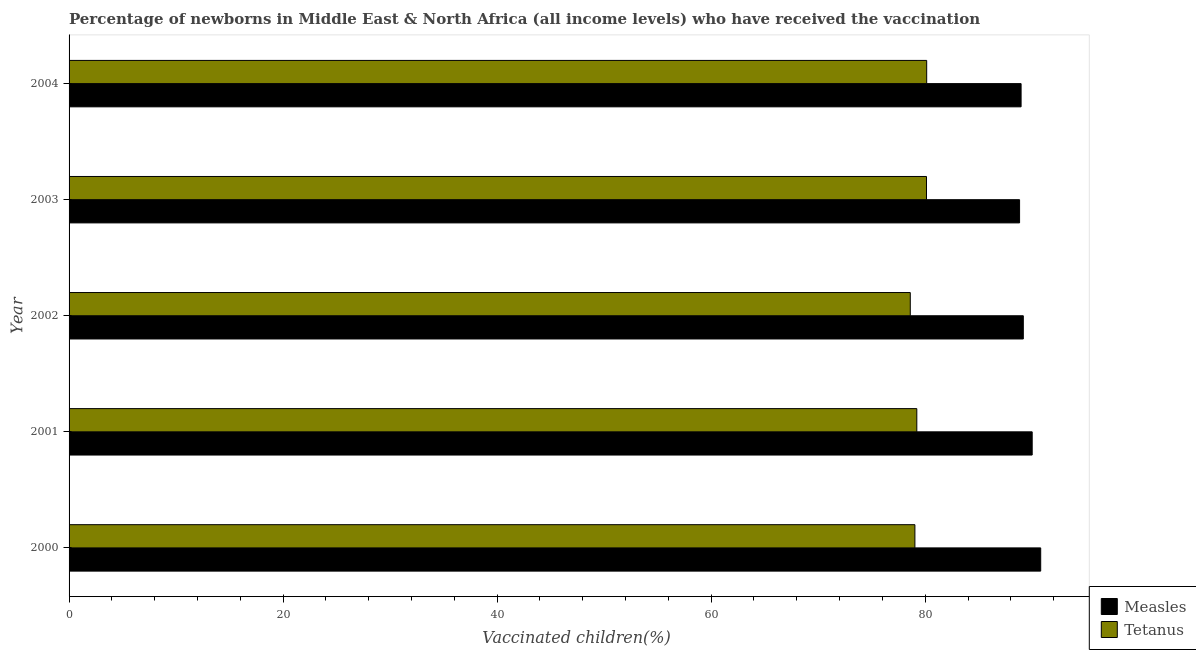How many different coloured bars are there?
Provide a succinct answer. 2. How many groups of bars are there?
Give a very brief answer. 5. Are the number of bars on each tick of the Y-axis equal?
Provide a short and direct response. Yes. How many bars are there on the 5th tick from the bottom?
Offer a terse response. 2. What is the percentage of newborns who received vaccination for measles in 2000?
Provide a succinct answer. 90.79. Across all years, what is the maximum percentage of newborns who received vaccination for tetanus?
Your response must be concise. 80.14. Across all years, what is the minimum percentage of newborns who received vaccination for tetanus?
Your response must be concise. 78.6. What is the total percentage of newborns who received vaccination for tetanus in the graph?
Make the answer very short. 397.11. What is the difference between the percentage of newborns who received vaccination for tetanus in 2000 and that in 2001?
Give a very brief answer. -0.18. What is the difference between the percentage of newborns who received vaccination for tetanus in 2000 and the percentage of newborns who received vaccination for measles in 2004?
Ensure brevity in your answer.  -9.92. What is the average percentage of newborns who received vaccination for tetanus per year?
Keep it short and to the point. 79.42. In the year 2003, what is the difference between the percentage of newborns who received vaccination for measles and percentage of newborns who received vaccination for tetanus?
Give a very brief answer. 8.7. In how many years, is the percentage of newborns who received vaccination for tetanus greater than 8 %?
Offer a terse response. 5. Is the percentage of newborns who received vaccination for tetanus in 2003 less than that in 2004?
Offer a terse response. Yes. What is the difference between the highest and the second highest percentage of newborns who received vaccination for tetanus?
Make the answer very short. 0.02. What is the difference between the highest and the lowest percentage of newborns who received vaccination for tetanus?
Your answer should be compact. 1.53. What does the 1st bar from the top in 2000 represents?
Ensure brevity in your answer.  Tetanus. What does the 1st bar from the bottom in 2001 represents?
Offer a terse response. Measles. How many bars are there?
Ensure brevity in your answer.  10. How many years are there in the graph?
Offer a terse response. 5. What is the difference between two consecutive major ticks on the X-axis?
Make the answer very short. 20. Are the values on the major ticks of X-axis written in scientific E-notation?
Your response must be concise. No. Does the graph contain any zero values?
Give a very brief answer. No. Does the graph contain grids?
Provide a succinct answer. No. Where does the legend appear in the graph?
Provide a short and direct response. Bottom right. How are the legend labels stacked?
Offer a terse response. Vertical. What is the title of the graph?
Make the answer very short. Percentage of newborns in Middle East & North Africa (all income levels) who have received the vaccination. What is the label or title of the X-axis?
Keep it short and to the point. Vaccinated children(%)
. What is the Vaccinated children(%)
 of Measles in 2000?
Provide a short and direct response. 90.79. What is the Vaccinated children(%)
 of Tetanus in 2000?
Offer a very short reply. 79.04. What is the Vaccinated children(%)
 of Measles in 2001?
Your answer should be compact. 90. What is the Vaccinated children(%)
 in Tetanus in 2001?
Give a very brief answer. 79.22. What is the Vaccinated children(%)
 in Measles in 2002?
Your response must be concise. 89.17. What is the Vaccinated children(%)
 in Tetanus in 2002?
Ensure brevity in your answer.  78.6. What is the Vaccinated children(%)
 of Measles in 2003?
Keep it short and to the point. 88.82. What is the Vaccinated children(%)
 in Tetanus in 2003?
Ensure brevity in your answer.  80.12. What is the Vaccinated children(%)
 of Measles in 2004?
Offer a terse response. 88.96. What is the Vaccinated children(%)
 of Tetanus in 2004?
Make the answer very short. 80.14. Across all years, what is the maximum Vaccinated children(%)
 in Measles?
Your answer should be very brief. 90.79. Across all years, what is the maximum Vaccinated children(%)
 in Tetanus?
Give a very brief answer. 80.14. Across all years, what is the minimum Vaccinated children(%)
 in Measles?
Your response must be concise. 88.82. Across all years, what is the minimum Vaccinated children(%)
 in Tetanus?
Offer a terse response. 78.6. What is the total Vaccinated children(%)
 in Measles in the graph?
Your answer should be compact. 447.73. What is the total Vaccinated children(%)
 in Tetanus in the graph?
Offer a very short reply. 397.11. What is the difference between the Vaccinated children(%)
 of Measles in 2000 and that in 2001?
Ensure brevity in your answer.  0.8. What is the difference between the Vaccinated children(%)
 of Tetanus in 2000 and that in 2001?
Keep it short and to the point. -0.18. What is the difference between the Vaccinated children(%)
 of Measles in 2000 and that in 2002?
Offer a terse response. 1.63. What is the difference between the Vaccinated children(%)
 of Tetanus in 2000 and that in 2002?
Your answer should be compact. 0.43. What is the difference between the Vaccinated children(%)
 of Measles in 2000 and that in 2003?
Your answer should be compact. 1.97. What is the difference between the Vaccinated children(%)
 in Tetanus in 2000 and that in 2003?
Provide a short and direct response. -1.08. What is the difference between the Vaccinated children(%)
 in Measles in 2000 and that in 2004?
Offer a very short reply. 1.83. What is the difference between the Vaccinated children(%)
 of Tetanus in 2000 and that in 2004?
Provide a succinct answer. -1.1. What is the difference between the Vaccinated children(%)
 of Measles in 2001 and that in 2002?
Offer a terse response. 0.83. What is the difference between the Vaccinated children(%)
 in Tetanus in 2001 and that in 2002?
Your answer should be compact. 0.61. What is the difference between the Vaccinated children(%)
 in Measles in 2001 and that in 2003?
Offer a very short reply. 1.18. What is the difference between the Vaccinated children(%)
 in Tetanus in 2001 and that in 2003?
Offer a very short reply. -0.91. What is the difference between the Vaccinated children(%)
 in Measles in 2001 and that in 2004?
Ensure brevity in your answer.  1.04. What is the difference between the Vaccinated children(%)
 in Tetanus in 2001 and that in 2004?
Provide a succinct answer. -0.92. What is the difference between the Vaccinated children(%)
 of Measles in 2002 and that in 2003?
Your answer should be compact. 0.35. What is the difference between the Vaccinated children(%)
 of Tetanus in 2002 and that in 2003?
Offer a terse response. -1.52. What is the difference between the Vaccinated children(%)
 of Measles in 2002 and that in 2004?
Provide a short and direct response. 0.21. What is the difference between the Vaccinated children(%)
 of Tetanus in 2002 and that in 2004?
Ensure brevity in your answer.  -1.53. What is the difference between the Vaccinated children(%)
 in Measles in 2003 and that in 2004?
Keep it short and to the point. -0.14. What is the difference between the Vaccinated children(%)
 in Tetanus in 2003 and that in 2004?
Your answer should be compact. -0.02. What is the difference between the Vaccinated children(%)
 in Measles in 2000 and the Vaccinated children(%)
 in Tetanus in 2001?
Your answer should be compact. 11.58. What is the difference between the Vaccinated children(%)
 in Measles in 2000 and the Vaccinated children(%)
 in Tetanus in 2002?
Give a very brief answer. 12.19. What is the difference between the Vaccinated children(%)
 in Measles in 2000 and the Vaccinated children(%)
 in Tetanus in 2003?
Your response must be concise. 10.67. What is the difference between the Vaccinated children(%)
 in Measles in 2000 and the Vaccinated children(%)
 in Tetanus in 2004?
Make the answer very short. 10.65. What is the difference between the Vaccinated children(%)
 of Measles in 2001 and the Vaccinated children(%)
 of Tetanus in 2002?
Offer a very short reply. 11.39. What is the difference between the Vaccinated children(%)
 in Measles in 2001 and the Vaccinated children(%)
 in Tetanus in 2003?
Give a very brief answer. 9.87. What is the difference between the Vaccinated children(%)
 in Measles in 2001 and the Vaccinated children(%)
 in Tetanus in 2004?
Make the answer very short. 9.86. What is the difference between the Vaccinated children(%)
 in Measles in 2002 and the Vaccinated children(%)
 in Tetanus in 2003?
Your answer should be compact. 9.05. What is the difference between the Vaccinated children(%)
 in Measles in 2002 and the Vaccinated children(%)
 in Tetanus in 2004?
Give a very brief answer. 9.03. What is the difference between the Vaccinated children(%)
 of Measles in 2003 and the Vaccinated children(%)
 of Tetanus in 2004?
Provide a succinct answer. 8.68. What is the average Vaccinated children(%)
 of Measles per year?
Offer a terse response. 89.55. What is the average Vaccinated children(%)
 in Tetanus per year?
Offer a terse response. 79.42. In the year 2000, what is the difference between the Vaccinated children(%)
 in Measles and Vaccinated children(%)
 in Tetanus?
Ensure brevity in your answer.  11.76. In the year 2001, what is the difference between the Vaccinated children(%)
 in Measles and Vaccinated children(%)
 in Tetanus?
Your answer should be compact. 10.78. In the year 2002, what is the difference between the Vaccinated children(%)
 in Measles and Vaccinated children(%)
 in Tetanus?
Your answer should be compact. 10.56. In the year 2003, what is the difference between the Vaccinated children(%)
 of Measles and Vaccinated children(%)
 of Tetanus?
Your response must be concise. 8.7. In the year 2004, what is the difference between the Vaccinated children(%)
 of Measles and Vaccinated children(%)
 of Tetanus?
Keep it short and to the point. 8.82. What is the ratio of the Vaccinated children(%)
 in Measles in 2000 to that in 2001?
Ensure brevity in your answer.  1.01. What is the ratio of the Vaccinated children(%)
 of Measles in 2000 to that in 2002?
Your answer should be compact. 1.02. What is the ratio of the Vaccinated children(%)
 in Tetanus in 2000 to that in 2002?
Give a very brief answer. 1.01. What is the ratio of the Vaccinated children(%)
 of Measles in 2000 to that in 2003?
Your answer should be compact. 1.02. What is the ratio of the Vaccinated children(%)
 in Tetanus in 2000 to that in 2003?
Make the answer very short. 0.99. What is the ratio of the Vaccinated children(%)
 in Measles in 2000 to that in 2004?
Give a very brief answer. 1.02. What is the ratio of the Vaccinated children(%)
 in Tetanus in 2000 to that in 2004?
Your answer should be compact. 0.99. What is the ratio of the Vaccinated children(%)
 of Measles in 2001 to that in 2002?
Provide a short and direct response. 1.01. What is the ratio of the Vaccinated children(%)
 of Measles in 2001 to that in 2003?
Your response must be concise. 1.01. What is the ratio of the Vaccinated children(%)
 in Tetanus in 2001 to that in 2003?
Provide a short and direct response. 0.99. What is the ratio of the Vaccinated children(%)
 of Measles in 2001 to that in 2004?
Your answer should be very brief. 1.01. What is the ratio of the Vaccinated children(%)
 of Tetanus in 2002 to that in 2003?
Provide a short and direct response. 0.98. What is the ratio of the Vaccinated children(%)
 of Tetanus in 2002 to that in 2004?
Give a very brief answer. 0.98. What is the ratio of the Vaccinated children(%)
 in Measles in 2003 to that in 2004?
Make the answer very short. 1. What is the ratio of the Vaccinated children(%)
 of Tetanus in 2003 to that in 2004?
Offer a terse response. 1. What is the difference between the highest and the second highest Vaccinated children(%)
 of Measles?
Keep it short and to the point. 0.8. What is the difference between the highest and the second highest Vaccinated children(%)
 in Tetanus?
Your answer should be compact. 0.02. What is the difference between the highest and the lowest Vaccinated children(%)
 of Measles?
Make the answer very short. 1.97. What is the difference between the highest and the lowest Vaccinated children(%)
 in Tetanus?
Your response must be concise. 1.53. 